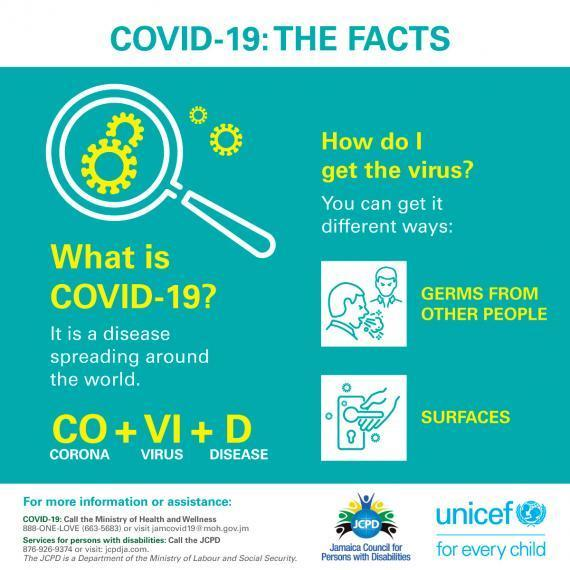What does VI stands for in COVID?
Answer the question with a short phrase. Virus What does the first two letters stands for in COVID-19? CORONA How many ways one can get corona virus? 2 How many facts about COVID-19 have been listed in the infographic? 3 Which is the second way through which one can get infected with corona? surfaces What does D stands for in COVID? disease Which are the ways through which one can get corona virus? germs from other people, surfaces 